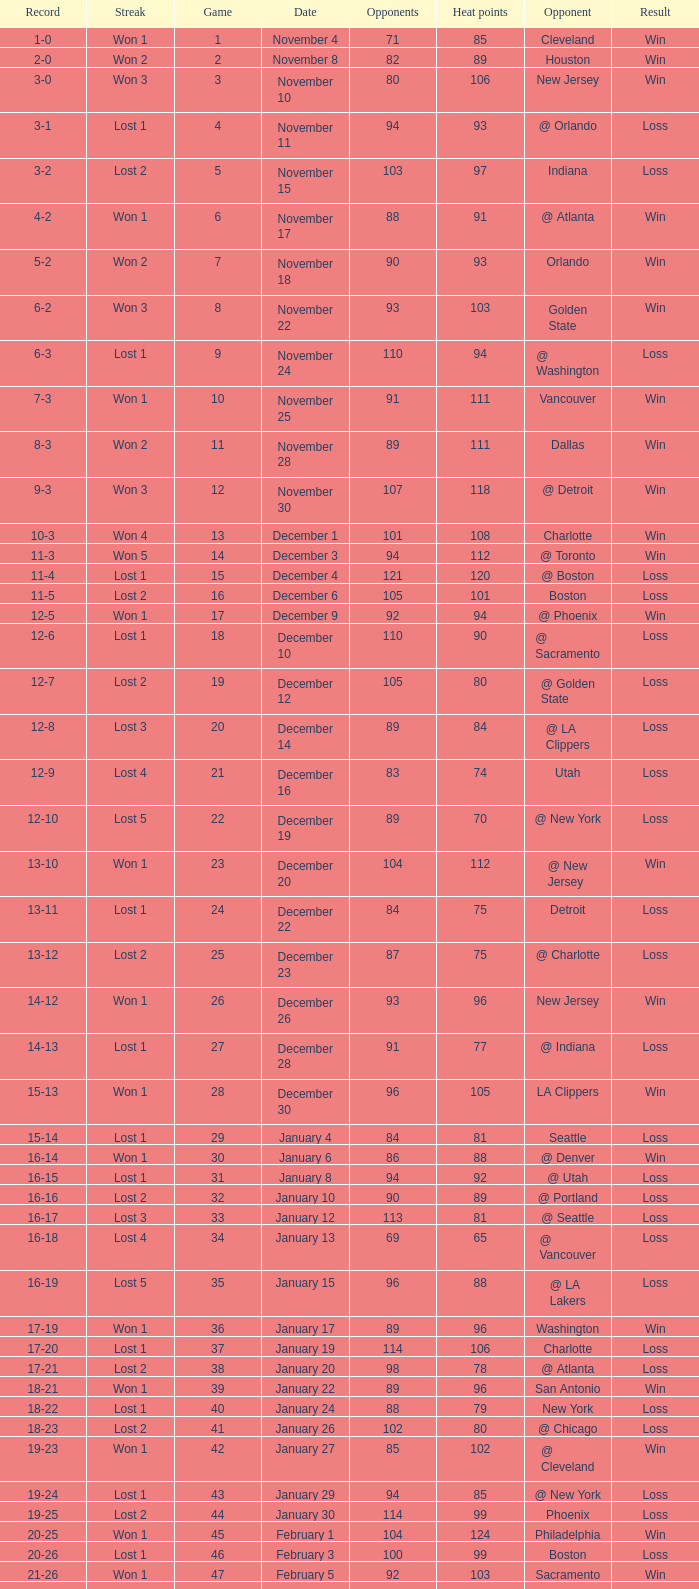What is Result, when Date is "December 12"? Loss. 